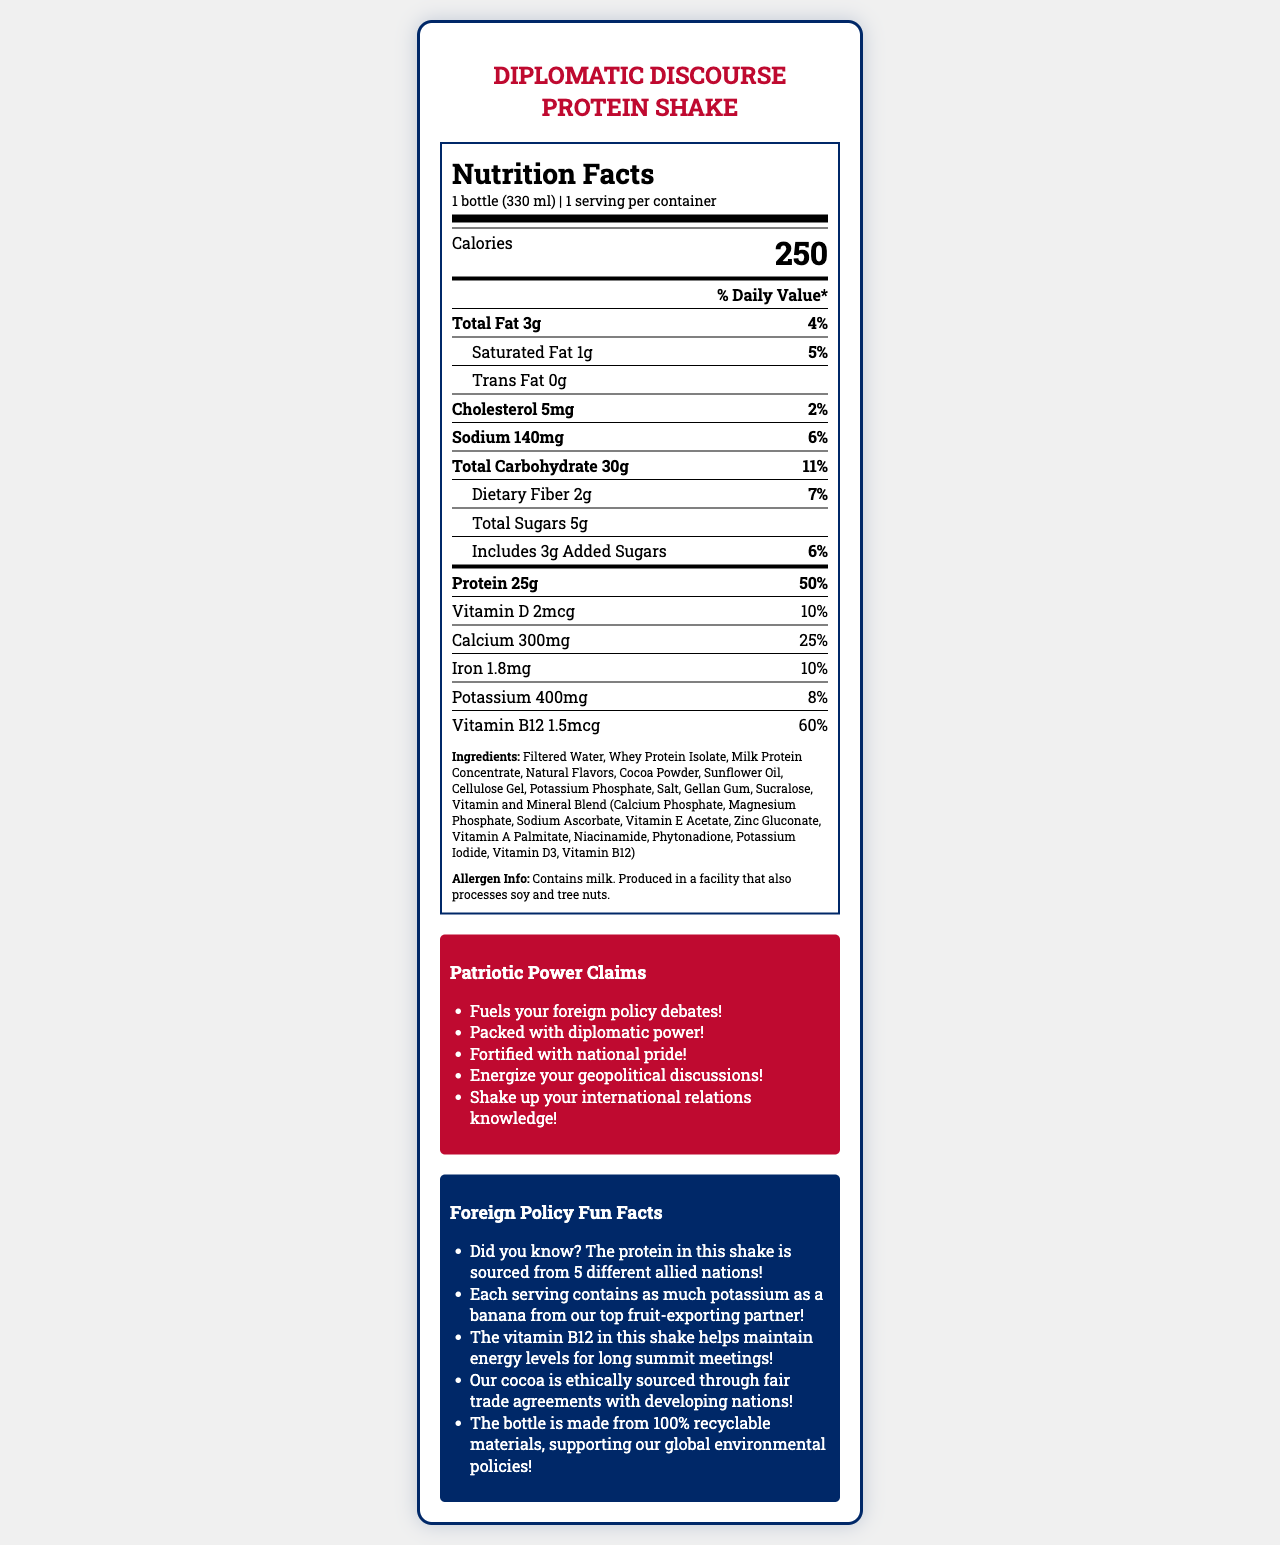what is the serving size for the Diplomatic Discourse Protein Shake? The serving size is explicitly stated as "1 bottle (330 ml)" in the document.
Answer: 1 bottle (330 ml) How many calories are in one serving of Diplomatic Discourse Protein Shake? The document lists the number of calories per serving as 250.
Answer: 250 calories What is the total amount of protein per serving? The document specifies that each serving contains 25 grams of protein.
Answer: 25g How much dietary fiber is in each serving? The document indicates that there are 2 grams of dietary fiber per serving.
Answer: 2g How much sodium is in one serving of Diplomatic Discourse Protein Shake? The sodium content per serving is listed as 140 milligrams.
Answer: 140mg How many servings are there per container? The document states that there is 1 serving per container.
Answer: 1 Which nutrient has the highest % Daily Value in this product? A. Vitamin D B. Calcium C. Vitamin B12 D. Iron The nutrient with the highest % Daily Value is Vitamin B12 at 60%.
Answer: C. Vitamin B12 What is the % Daily Value for saturated fat? A. 2% B. 4% C. 5% D. 6% The % Daily Value for saturated fat is listed as 5%.
Answer: C. 5% Does the Diplomatic Discourse Protein Shake contain any trans fat? The document lists the trans fat amount as 0 grams, indicating no trans fat.
Answer: No Is there any allergen information available? The document specifies that the product contains milk and is produced in a facility that also processes soy and tree nuts.
Answer: Yes Describe the overall theme and purpose of this document. The document is centered around the nutritional composition of the protein shake and is tailored to appeal to those interested in foreign policy by incorporating patriotic and geopolitical elements.
Answer: The document is a detailed Nutrition Facts Label for a protein shake marketed as "Fuel for Foreign Policy Discussions". It includes nutritional information, ingredient list, allergen information, patriotic marketing claims, and foreign policy fun facts to engage a patriotic audience. How many foreign allies are involved in sourcing the protein for this shake? The document mentions that the protein is sourced from 5 different allied nations, but it does not specify which countries are these allies.
Answer: Cannot be determined 